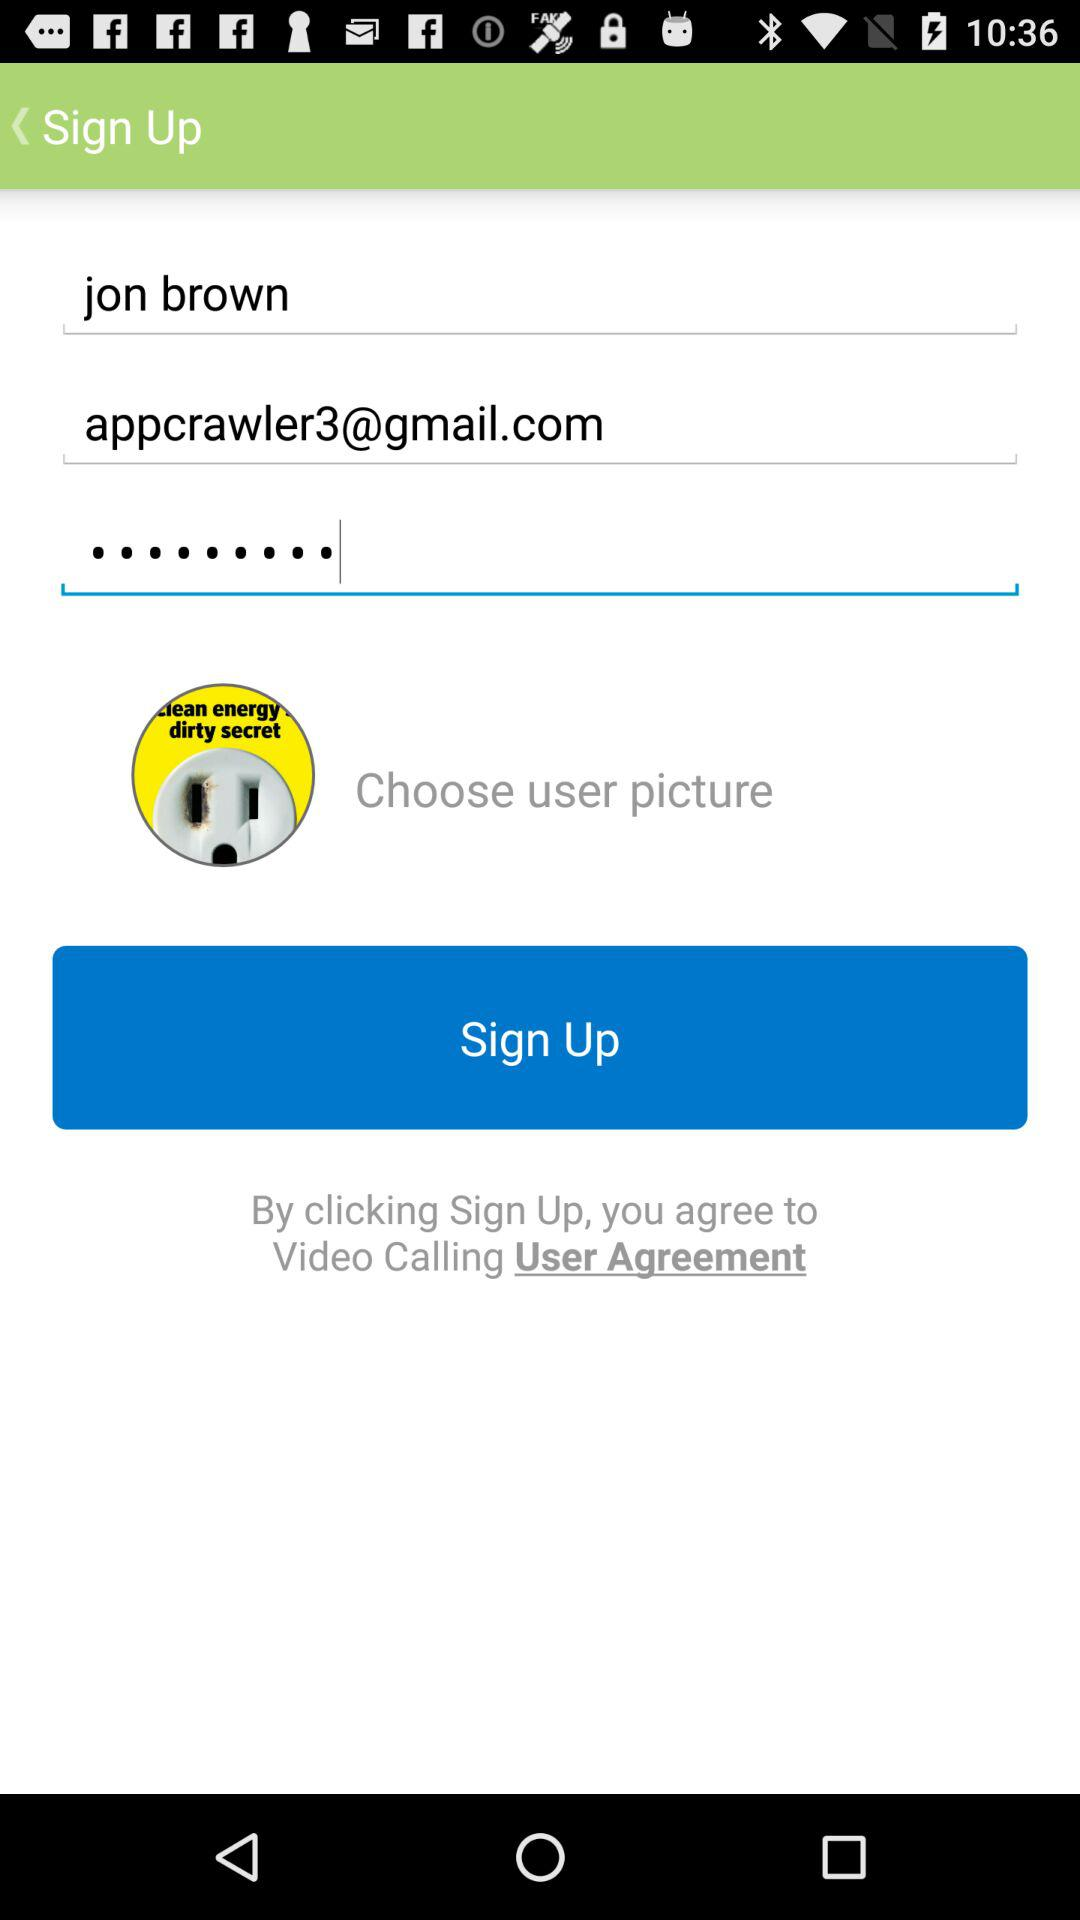What is the email address? The email address is appcrawler3@gmail.com. 